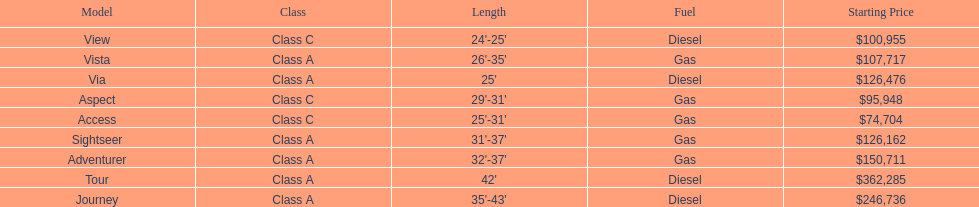Which model had the highest starting price Tour. 